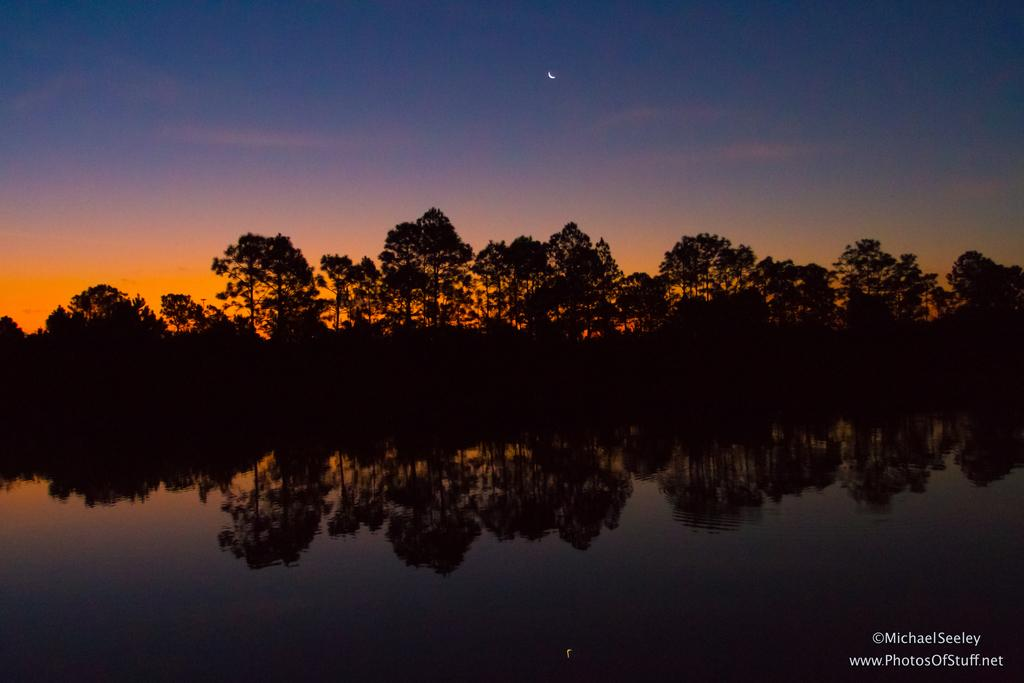What is one of the main elements in the image? There is water in the image. What else can be seen in the image besides water? There are trees and the sky visible in the image. Can you describe the sky in the image? The sky has a half moon in it. What is the reflection of in the water? The reflection of trees can be seen on the water. Is there any additional mark or feature in the image? Yes, there is a water mark in the bottom right corner of the image. What type of jail can be seen in the image? There is no jail present in the image. How does the system work in the image? The image does not depict a system or process, so it cannot be determined how it works. 